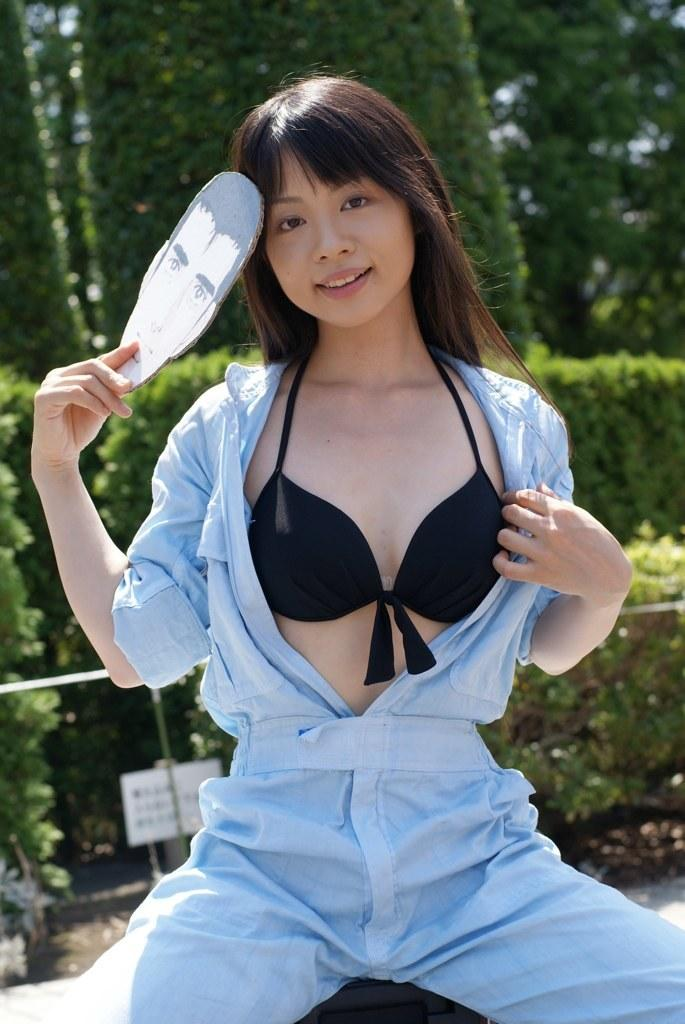What is the woman in the image doing? The woman is sitting in the image. What is the woman holding in the image? The woman is holding an object. What can be seen in the background of the image? There are trees in the background of the image. What is the board in the image used for? The facts provided do not specify the purpose of the board in the image. Are there any fairies visible in the image? There is no mention of fairies in the image, so we cannot confirm their presence. 